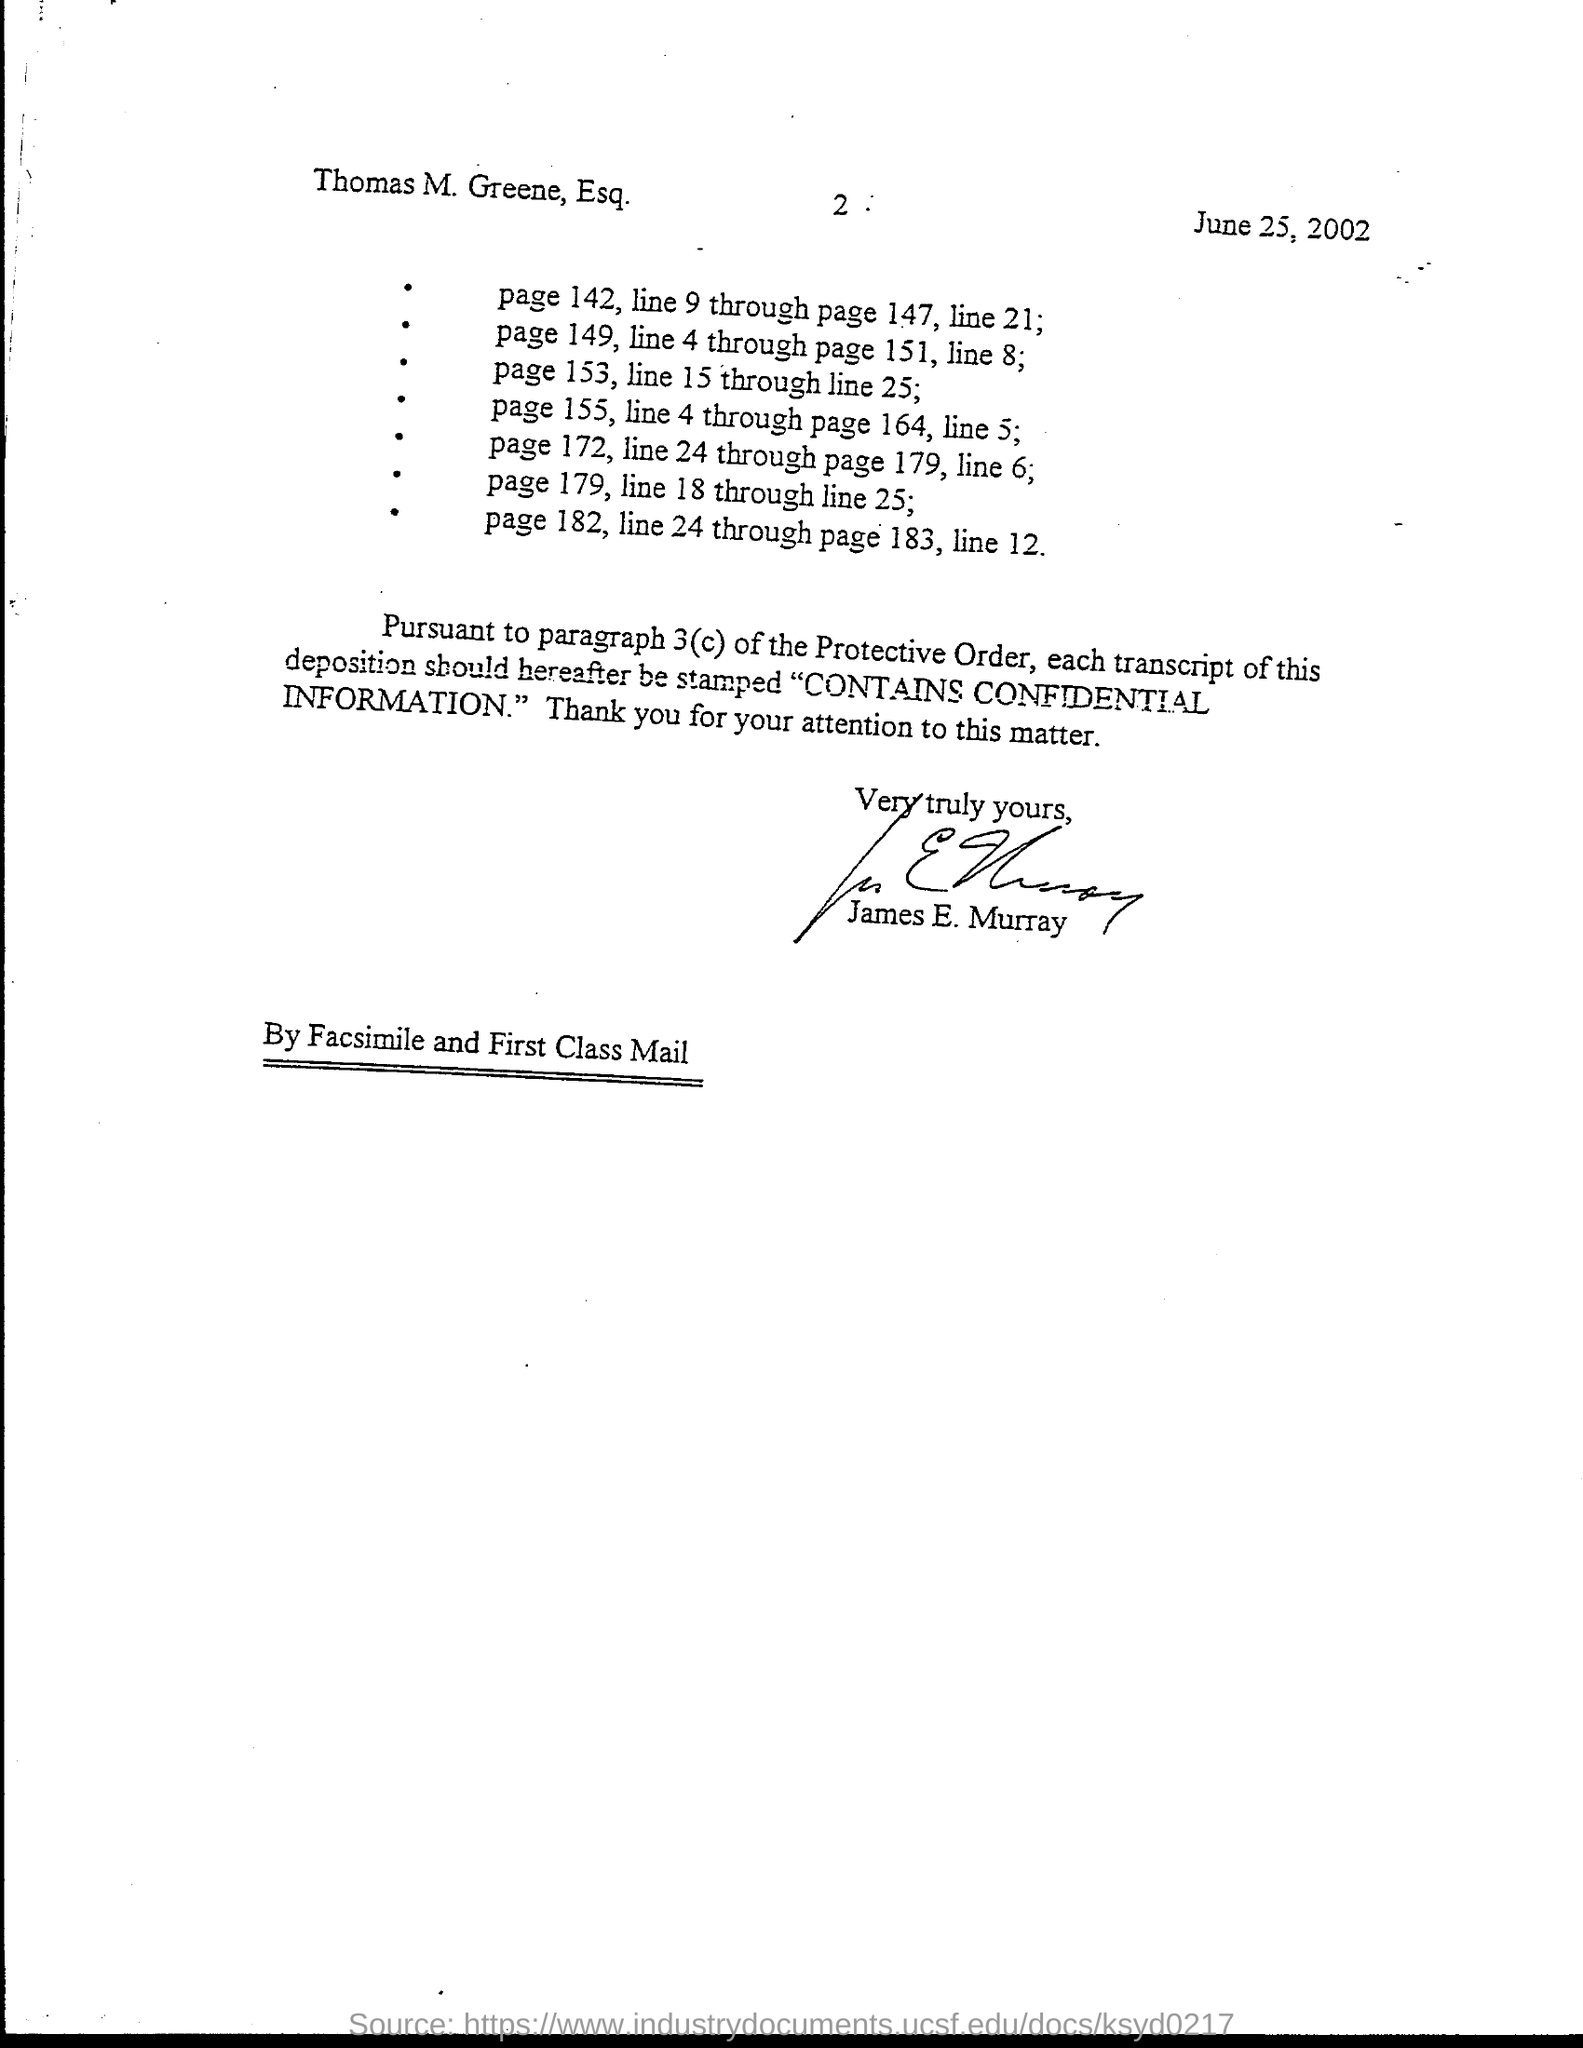Highlight a few significant elements in this photo. The document contains the date of June 25, 2002. James E. Murray has signed this document. 